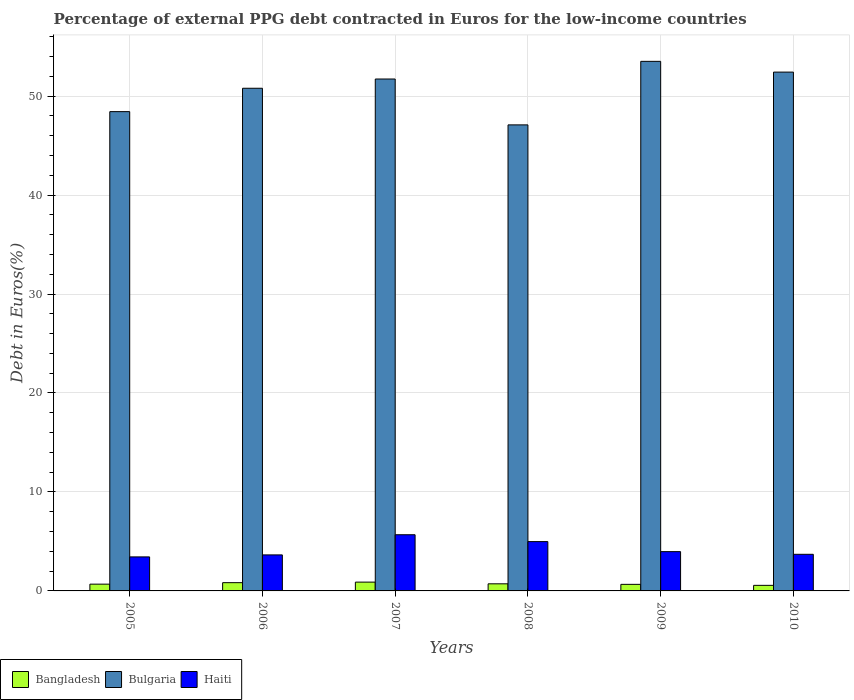How many different coloured bars are there?
Offer a terse response. 3. How many groups of bars are there?
Your answer should be very brief. 6. Are the number of bars on each tick of the X-axis equal?
Make the answer very short. Yes. In how many cases, is the number of bars for a given year not equal to the number of legend labels?
Offer a very short reply. 0. What is the percentage of external PPG debt contracted in Euros in Bangladesh in 2008?
Make the answer very short. 0.72. Across all years, what is the maximum percentage of external PPG debt contracted in Euros in Haiti?
Give a very brief answer. 5.68. Across all years, what is the minimum percentage of external PPG debt contracted in Euros in Bangladesh?
Provide a short and direct response. 0.56. In which year was the percentage of external PPG debt contracted in Euros in Bangladesh maximum?
Your answer should be very brief. 2007. What is the total percentage of external PPG debt contracted in Euros in Bangladesh in the graph?
Give a very brief answer. 4.35. What is the difference between the percentage of external PPG debt contracted in Euros in Bangladesh in 2008 and that in 2010?
Provide a short and direct response. 0.15. What is the difference between the percentage of external PPG debt contracted in Euros in Bulgaria in 2005 and the percentage of external PPG debt contracted in Euros in Haiti in 2006?
Your response must be concise. 44.79. What is the average percentage of external PPG debt contracted in Euros in Bangladesh per year?
Provide a succinct answer. 0.73. In the year 2005, what is the difference between the percentage of external PPG debt contracted in Euros in Haiti and percentage of external PPG debt contracted in Euros in Bulgaria?
Ensure brevity in your answer.  -44.99. What is the ratio of the percentage of external PPG debt contracted in Euros in Bulgaria in 2006 to that in 2010?
Your answer should be compact. 0.97. What is the difference between the highest and the second highest percentage of external PPG debt contracted in Euros in Bulgaria?
Your answer should be compact. 1.09. What is the difference between the highest and the lowest percentage of external PPG debt contracted in Euros in Bulgaria?
Ensure brevity in your answer.  6.42. What does the 1st bar from the right in 2008 represents?
Offer a terse response. Haiti. Is it the case that in every year, the sum of the percentage of external PPG debt contracted in Euros in Bulgaria and percentage of external PPG debt contracted in Euros in Haiti is greater than the percentage of external PPG debt contracted in Euros in Bangladesh?
Make the answer very short. Yes. How many bars are there?
Your answer should be compact. 18. Are all the bars in the graph horizontal?
Your response must be concise. No. How are the legend labels stacked?
Offer a very short reply. Horizontal. What is the title of the graph?
Provide a short and direct response. Percentage of external PPG debt contracted in Euros for the low-income countries. Does "Russian Federation" appear as one of the legend labels in the graph?
Offer a terse response. No. What is the label or title of the X-axis?
Offer a terse response. Years. What is the label or title of the Y-axis?
Make the answer very short. Debt in Euros(%). What is the Debt in Euros(%) in Bangladesh in 2005?
Give a very brief answer. 0.68. What is the Debt in Euros(%) of Bulgaria in 2005?
Your answer should be compact. 48.43. What is the Debt in Euros(%) of Haiti in 2005?
Provide a short and direct response. 3.44. What is the Debt in Euros(%) of Bangladesh in 2006?
Offer a terse response. 0.83. What is the Debt in Euros(%) of Bulgaria in 2006?
Keep it short and to the point. 50.79. What is the Debt in Euros(%) in Haiti in 2006?
Make the answer very short. 3.64. What is the Debt in Euros(%) in Bangladesh in 2007?
Your response must be concise. 0.89. What is the Debt in Euros(%) of Bulgaria in 2007?
Ensure brevity in your answer.  51.72. What is the Debt in Euros(%) of Haiti in 2007?
Offer a terse response. 5.68. What is the Debt in Euros(%) of Bangladesh in 2008?
Make the answer very short. 0.72. What is the Debt in Euros(%) in Bulgaria in 2008?
Give a very brief answer. 47.09. What is the Debt in Euros(%) in Haiti in 2008?
Give a very brief answer. 4.98. What is the Debt in Euros(%) in Bangladesh in 2009?
Make the answer very short. 0.66. What is the Debt in Euros(%) in Bulgaria in 2009?
Your answer should be compact. 53.51. What is the Debt in Euros(%) of Haiti in 2009?
Offer a very short reply. 3.97. What is the Debt in Euros(%) in Bangladesh in 2010?
Provide a succinct answer. 0.56. What is the Debt in Euros(%) of Bulgaria in 2010?
Provide a short and direct response. 52.42. What is the Debt in Euros(%) in Haiti in 2010?
Offer a terse response. 3.7. Across all years, what is the maximum Debt in Euros(%) of Bangladesh?
Make the answer very short. 0.89. Across all years, what is the maximum Debt in Euros(%) in Bulgaria?
Provide a succinct answer. 53.51. Across all years, what is the maximum Debt in Euros(%) in Haiti?
Keep it short and to the point. 5.68. Across all years, what is the minimum Debt in Euros(%) of Bangladesh?
Provide a succinct answer. 0.56. Across all years, what is the minimum Debt in Euros(%) in Bulgaria?
Give a very brief answer. 47.09. Across all years, what is the minimum Debt in Euros(%) in Haiti?
Keep it short and to the point. 3.44. What is the total Debt in Euros(%) of Bangladesh in the graph?
Give a very brief answer. 4.35. What is the total Debt in Euros(%) in Bulgaria in the graph?
Your answer should be compact. 303.97. What is the total Debt in Euros(%) in Haiti in the graph?
Your response must be concise. 25.41. What is the difference between the Debt in Euros(%) in Bangladesh in 2005 and that in 2006?
Make the answer very short. -0.15. What is the difference between the Debt in Euros(%) in Bulgaria in 2005 and that in 2006?
Offer a very short reply. -2.36. What is the difference between the Debt in Euros(%) of Haiti in 2005 and that in 2006?
Keep it short and to the point. -0.2. What is the difference between the Debt in Euros(%) of Bangladesh in 2005 and that in 2007?
Keep it short and to the point. -0.21. What is the difference between the Debt in Euros(%) of Bulgaria in 2005 and that in 2007?
Provide a succinct answer. -3.3. What is the difference between the Debt in Euros(%) of Haiti in 2005 and that in 2007?
Offer a very short reply. -2.24. What is the difference between the Debt in Euros(%) of Bangladesh in 2005 and that in 2008?
Ensure brevity in your answer.  -0.03. What is the difference between the Debt in Euros(%) of Bulgaria in 2005 and that in 2008?
Your response must be concise. 1.34. What is the difference between the Debt in Euros(%) of Haiti in 2005 and that in 2008?
Ensure brevity in your answer.  -1.54. What is the difference between the Debt in Euros(%) of Bangladesh in 2005 and that in 2009?
Your answer should be very brief. 0.02. What is the difference between the Debt in Euros(%) in Bulgaria in 2005 and that in 2009?
Your answer should be compact. -5.08. What is the difference between the Debt in Euros(%) of Haiti in 2005 and that in 2009?
Provide a short and direct response. -0.53. What is the difference between the Debt in Euros(%) of Bangladesh in 2005 and that in 2010?
Offer a terse response. 0.12. What is the difference between the Debt in Euros(%) in Bulgaria in 2005 and that in 2010?
Your answer should be very brief. -3.99. What is the difference between the Debt in Euros(%) of Haiti in 2005 and that in 2010?
Your response must be concise. -0.26. What is the difference between the Debt in Euros(%) of Bangladesh in 2006 and that in 2007?
Provide a succinct answer. -0.06. What is the difference between the Debt in Euros(%) of Bulgaria in 2006 and that in 2007?
Your answer should be compact. -0.93. What is the difference between the Debt in Euros(%) in Haiti in 2006 and that in 2007?
Give a very brief answer. -2.04. What is the difference between the Debt in Euros(%) in Bangladesh in 2006 and that in 2008?
Give a very brief answer. 0.12. What is the difference between the Debt in Euros(%) of Bulgaria in 2006 and that in 2008?
Give a very brief answer. 3.7. What is the difference between the Debt in Euros(%) in Haiti in 2006 and that in 2008?
Offer a terse response. -1.34. What is the difference between the Debt in Euros(%) in Bangladesh in 2006 and that in 2009?
Provide a succinct answer. 0.17. What is the difference between the Debt in Euros(%) of Bulgaria in 2006 and that in 2009?
Make the answer very short. -2.72. What is the difference between the Debt in Euros(%) of Haiti in 2006 and that in 2009?
Keep it short and to the point. -0.33. What is the difference between the Debt in Euros(%) of Bangladesh in 2006 and that in 2010?
Your answer should be very brief. 0.27. What is the difference between the Debt in Euros(%) of Bulgaria in 2006 and that in 2010?
Give a very brief answer. -1.63. What is the difference between the Debt in Euros(%) in Haiti in 2006 and that in 2010?
Your answer should be very brief. -0.06. What is the difference between the Debt in Euros(%) in Bangladesh in 2007 and that in 2008?
Your answer should be very brief. 0.17. What is the difference between the Debt in Euros(%) in Bulgaria in 2007 and that in 2008?
Give a very brief answer. 4.63. What is the difference between the Debt in Euros(%) in Haiti in 2007 and that in 2008?
Offer a terse response. 0.69. What is the difference between the Debt in Euros(%) in Bangladesh in 2007 and that in 2009?
Keep it short and to the point. 0.23. What is the difference between the Debt in Euros(%) in Bulgaria in 2007 and that in 2009?
Offer a very short reply. -1.78. What is the difference between the Debt in Euros(%) of Haiti in 2007 and that in 2009?
Provide a succinct answer. 1.71. What is the difference between the Debt in Euros(%) of Bangladesh in 2007 and that in 2010?
Your response must be concise. 0.33. What is the difference between the Debt in Euros(%) of Bulgaria in 2007 and that in 2010?
Your response must be concise. -0.7. What is the difference between the Debt in Euros(%) in Haiti in 2007 and that in 2010?
Give a very brief answer. 1.98. What is the difference between the Debt in Euros(%) in Bangladesh in 2008 and that in 2009?
Provide a succinct answer. 0.05. What is the difference between the Debt in Euros(%) of Bulgaria in 2008 and that in 2009?
Provide a short and direct response. -6.42. What is the difference between the Debt in Euros(%) in Haiti in 2008 and that in 2009?
Keep it short and to the point. 1.01. What is the difference between the Debt in Euros(%) in Bangladesh in 2008 and that in 2010?
Keep it short and to the point. 0.15. What is the difference between the Debt in Euros(%) in Bulgaria in 2008 and that in 2010?
Keep it short and to the point. -5.33. What is the difference between the Debt in Euros(%) in Haiti in 2008 and that in 2010?
Ensure brevity in your answer.  1.28. What is the difference between the Debt in Euros(%) of Bangladesh in 2009 and that in 2010?
Offer a very short reply. 0.1. What is the difference between the Debt in Euros(%) of Bulgaria in 2009 and that in 2010?
Offer a very short reply. 1.09. What is the difference between the Debt in Euros(%) in Haiti in 2009 and that in 2010?
Your answer should be compact. 0.27. What is the difference between the Debt in Euros(%) of Bangladesh in 2005 and the Debt in Euros(%) of Bulgaria in 2006?
Ensure brevity in your answer.  -50.11. What is the difference between the Debt in Euros(%) in Bangladesh in 2005 and the Debt in Euros(%) in Haiti in 2006?
Give a very brief answer. -2.96. What is the difference between the Debt in Euros(%) in Bulgaria in 2005 and the Debt in Euros(%) in Haiti in 2006?
Offer a terse response. 44.79. What is the difference between the Debt in Euros(%) of Bangladesh in 2005 and the Debt in Euros(%) of Bulgaria in 2007?
Make the answer very short. -51.04. What is the difference between the Debt in Euros(%) of Bangladesh in 2005 and the Debt in Euros(%) of Haiti in 2007?
Provide a succinct answer. -4.99. What is the difference between the Debt in Euros(%) of Bulgaria in 2005 and the Debt in Euros(%) of Haiti in 2007?
Your answer should be very brief. 42.75. What is the difference between the Debt in Euros(%) in Bangladesh in 2005 and the Debt in Euros(%) in Bulgaria in 2008?
Offer a very short reply. -46.41. What is the difference between the Debt in Euros(%) in Bangladesh in 2005 and the Debt in Euros(%) in Haiti in 2008?
Your answer should be compact. -4.3. What is the difference between the Debt in Euros(%) of Bulgaria in 2005 and the Debt in Euros(%) of Haiti in 2008?
Your response must be concise. 43.45. What is the difference between the Debt in Euros(%) of Bangladesh in 2005 and the Debt in Euros(%) of Bulgaria in 2009?
Give a very brief answer. -52.82. What is the difference between the Debt in Euros(%) of Bangladesh in 2005 and the Debt in Euros(%) of Haiti in 2009?
Make the answer very short. -3.29. What is the difference between the Debt in Euros(%) of Bulgaria in 2005 and the Debt in Euros(%) of Haiti in 2009?
Make the answer very short. 44.46. What is the difference between the Debt in Euros(%) of Bangladesh in 2005 and the Debt in Euros(%) of Bulgaria in 2010?
Keep it short and to the point. -51.74. What is the difference between the Debt in Euros(%) in Bangladesh in 2005 and the Debt in Euros(%) in Haiti in 2010?
Give a very brief answer. -3.02. What is the difference between the Debt in Euros(%) in Bulgaria in 2005 and the Debt in Euros(%) in Haiti in 2010?
Your answer should be compact. 44.73. What is the difference between the Debt in Euros(%) in Bangladesh in 2006 and the Debt in Euros(%) in Bulgaria in 2007?
Your response must be concise. -50.89. What is the difference between the Debt in Euros(%) in Bangladesh in 2006 and the Debt in Euros(%) in Haiti in 2007?
Keep it short and to the point. -4.84. What is the difference between the Debt in Euros(%) of Bulgaria in 2006 and the Debt in Euros(%) of Haiti in 2007?
Offer a very short reply. 45.11. What is the difference between the Debt in Euros(%) in Bangladesh in 2006 and the Debt in Euros(%) in Bulgaria in 2008?
Offer a very short reply. -46.26. What is the difference between the Debt in Euros(%) in Bangladesh in 2006 and the Debt in Euros(%) in Haiti in 2008?
Your answer should be compact. -4.15. What is the difference between the Debt in Euros(%) in Bulgaria in 2006 and the Debt in Euros(%) in Haiti in 2008?
Provide a succinct answer. 45.81. What is the difference between the Debt in Euros(%) in Bangladesh in 2006 and the Debt in Euros(%) in Bulgaria in 2009?
Your answer should be very brief. -52.67. What is the difference between the Debt in Euros(%) in Bangladesh in 2006 and the Debt in Euros(%) in Haiti in 2009?
Your response must be concise. -3.13. What is the difference between the Debt in Euros(%) in Bulgaria in 2006 and the Debt in Euros(%) in Haiti in 2009?
Ensure brevity in your answer.  46.82. What is the difference between the Debt in Euros(%) of Bangladesh in 2006 and the Debt in Euros(%) of Bulgaria in 2010?
Keep it short and to the point. -51.59. What is the difference between the Debt in Euros(%) of Bangladesh in 2006 and the Debt in Euros(%) of Haiti in 2010?
Keep it short and to the point. -2.87. What is the difference between the Debt in Euros(%) of Bulgaria in 2006 and the Debt in Euros(%) of Haiti in 2010?
Your answer should be very brief. 47.09. What is the difference between the Debt in Euros(%) of Bangladesh in 2007 and the Debt in Euros(%) of Bulgaria in 2008?
Ensure brevity in your answer.  -46.2. What is the difference between the Debt in Euros(%) of Bangladesh in 2007 and the Debt in Euros(%) of Haiti in 2008?
Provide a succinct answer. -4.09. What is the difference between the Debt in Euros(%) of Bulgaria in 2007 and the Debt in Euros(%) of Haiti in 2008?
Your answer should be very brief. 46.74. What is the difference between the Debt in Euros(%) of Bangladesh in 2007 and the Debt in Euros(%) of Bulgaria in 2009?
Give a very brief answer. -52.62. What is the difference between the Debt in Euros(%) in Bangladesh in 2007 and the Debt in Euros(%) in Haiti in 2009?
Provide a short and direct response. -3.08. What is the difference between the Debt in Euros(%) of Bulgaria in 2007 and the Debt in Euros(%) of Haiti in 2009?
Offer a terse response. 47.76. What is the difference between the Debt in Euros(%) in Bangladesh in 2007 and the Debt in Euros(%) in Bulgaria in 2010?
Keep it short and to the point. -51.53. What is the difference between the Debt in Euros(%) in Bangladesh in 2007 and the Debt in Euros(%) in Haiti in 2010?
Make the answer very short. -2.81. What is the difference between the Debt in Euros(%) in Bulgaria in 2007 and the Debt in Euros(%) in Haiti in 2010?
Make the answer very short. 48.03. What is the difference between the Debt in Euros(%) in Bangladesh in 2008 and the Debt in Euros(%) in Bulgaria in 2009?
Your answer should be very brief. -52.79. What is the difference between the Debt in Euros(%) in Bangladesh in 2008 and the Debt in Euros(%) in Haiti in 2009?
Offer a terse response. -3.25. What is the difference between the Debt in Euros(%) of Bulgaria in 2008 and the Debt in Euros(%) of Haiti in 2009?
Offer a very short reply. 43.12. What is the difference between the Debt in Euros(%) of Bangladesh in 2008 and the Debt in Euros(%) of Bulgaria in 2010?
Offer a very short reply. -51.71. What is the difference between the Debt in Euros(%) of Bangladesh in 2008 and the Debt in Euros(%) of Haiti in 2010?
Offer a terse response. -2.98. What is the difference between the Debt in Euros(%) of Bulgaria in 2008 and the Debt in Euros(%) of Haiti in 2010?
Offer a very short reply. 43.39. What is the difference between the Debt in Euros(%) in Bangladesh in 2009 and the Debt in Euros(%) in Bulgaria in 2010?
Provide a succinct answer. -51.76. What is the difference between the Debt in Euros(%) of Bangladesh in 2009 and the Debt in Euros(%) of Haiti in 2010?
Give a very brief answer. -3.04. What is the difference between the Debt in Euros(%) in Bulgaria in 2009 and the Debt in Euros(%) in Haiti in 2010?
Keep it short and to the point. 49.81. What is the average Debt in Euros(%) in Bangladesh per year?
Offer a terse response. 0.73. What is the average Debt in Euros(%) of Bulgaria per year?
Provide a succinct answer. 50.66. What is the average Debt in Euros(%) of Haiti per year?
Keep it short and to the point. 4.23. In the year 2005, what is the difference between the Debt in Euros(%) in Bangladesh and Debt in Euros(%) in Bulgaria?
Offer a terse response. -47.74. In the year 2005, what is the difference between the Debt in Euros(%) of Bangladesh and Debt in Euros(%) of Haiti?
Make the answer very short. -2.75. In the year 2005, what is the difference between the Debt in Euros(%) in Bulgaria and Debt in Euros(%) in Haiti?
Your answer should be very brief. 44.99. In the year 2006, what is the difference between the Debt in Euros(%) of Bangladesh and Debt in Euros(%) of Bulgaria?
Provide a short and direct response. -49.96. In the year 2006, what is the difference between the Debt in Euros(%) of Bangladesh and Debt in Euros(%) of Haiti?
Give a very brief answer. -2.81. In the year 2006, what is the difference between the Debt in Euros(%) in Bulgaria and Debt in Euros(%) in Haiti?
Your response must be concise. 47.15. In the year 2007, what is the difference between the Debt in Euros(%) in Bangladesh and Debt in Euros(%) in Bulgaria?
Your answer should be very brief. -50.84. In the year 2007, what is the difference between the Debt in Euros(%) in Bangladesh and Debt in Euros(%) in Haiti?
Your response must be concise. -4.79. In the year 2007, what is the difference between the Debt in Euros(%) in Bulgaria and Debt in Euros(%) in Haiti?
Offer a very short reply. 46.05. In the year 2008, what is the difference between the Debt in Euros(%) in Bangladesh and Debt in Euros(%) in Bulgaria?
Ensure brevity in your answer.  -46.37. In the year 2008, what is the difference between the Debt in Euros(%) of Bangladesh and Debt in Euros(%) of Haiti?
Keep it short and to the point. -4.26. In the year 2008, what is the difference between the Debt in Euros(%) of Bulgaria and Debt in Euros(%) of Haiti?
Ensure brevity in your answer.  42.11. In the year 2009, what is the difference between the Debt in Euros(%) in Bangladesh and Debt in Euros(%) in Bulgaria?
Keep it short and to the point. -52.84. In the year 2009, what is the difference between the Debt in Euros(%) in Bangladesh and Debt in Euros(%) in Haiti?
Ensure brevity in your answer.  -3.31. In the year 2009, what is the difference between the Debt in Euros(%) of Bulgaria and Debt in Euros(%) of Haiti?
Provide a short and direct response. 49.54. In the year 2010, what is the difference between the Debt in Euros(%) of Bangladesh and Debt in Euros(%) of Bulgaria?
Make the answer very short. -51.86. In the year 2010, what is the difference between the Debt in Euros(%) in Bangladesh and Debt in Euros(%) in Haiti?
Give a very brief answer. -3.14. In the year 2010, what is the difference between the Debt in Euros(%) in Bulgaria and Debt in Euros(%) in Haiti?
Provide a succinct answer. 48.72. What is the ratio of the Debt in Euros(%) of Bangladesh in 2005 to that in 2006?
Ensure brevity in your answer.  0.82. What is the ratio of the Debt in Euros(%) of Bulgaria in 2005 to that in 2006?
Your response must be concise. 0.95. What is the ratio of the Debt in Euros(%) of Haiti in 2005 to that in 2006?
Your response must be concise. 0.94. What is the ratio of the Debt in Euros(%) in Bangladesh in 2005 to that in 2007?
Your answer should be compact. 0.77. What is the ratio of the Debt in Euros(%) of Bulgaria in 2005 to that in 2007?
Provide a short and direct response. 0.94. What is the ratio of the Debt in Euros(%) of Haiti in 2005 to that in 2007?
Keep it short and to the point. 0.61. What is the ratio of the Debt in Euros(%) of Bangladesh in 2005 to that in 2008?
Your answer should be compact. 0.95. What is the ratio of the Debt in Euros(%) of Bulgaria in 2005 to that in 2008?
Offer a terse response. 1.03. What is the ratio of the Debt in Euros(%) of Haiti in 2005 to that in 2008?
Offer a terse response. 0.69. What is the ratio of the Debt in Euros(%) of Bangladesh in 2005 to that in 2009?
Give a very brief answer. 1.03. What is the ratio of the Debt in Euros(%) in Bulgaria in 2005 to that in 2009?
Make the answer very short. 0.91. What is the ratio of the Debt in Euros(%) in Haiti in 2005 to that in 2009?
Offer a very short reply. 0.87. What is the ratio of the Debt in Euros(%) of Bangladesh in 2005 to that in 2010?
Make the answer very short. 1.22. What is the ratio of the Debt in Euros(%) of Bulgaria in 2005 to that in 2010?
Provide a short and direct response. 0.92. What is the ratio of the Debt in Euros(%) in Haiti in 2005 to that in 2010?
Offer a very short reply. 0.93. What is the ratio of the Debt in Euros(%) in Bangladesh in 2006 to that in 2007?
Give a very brief answer. 0.94. What is the ratio of the Debt in Euros(%) of Bulgaria in 2006 to that in 2007?
Your answer should be compact. 0.98. What is the ratio of the Debt in Euros(%) in Haiti in 2006 to that in 2007?
Offer a terse response. 0.64. What is the ratio of the Debt in Euros(%) in Bangladesh in 2006 to that in 2008?
Your answer should be very brief. 1.16. What is the ratio of the Debt in Euros(%) in Bulgaria in 2006 to that in 2008?
Provide a short and direct response. 1.08. What is the ratio of the Debt in Euros(%) of Haiti in 2006 to that in 2008?
Your answer should be very brief. 0.73. What is the ratio of the Debt in Euros(%) of Bangladesh in 2006 to that in 2009?
Ensure brevity in your answer.  1.26. What is the ratio of the Debt in Euros(%) of Bulgaria in 2006 to that in 2009?
Give a very brief answer. 0.95. What is the ratio of the Debt in Euros(%) in Haiti in 2006 to that in 2009?
Provide a succinct answer. 0.92. What is the ratio of the Debt in Euros(%) in Bangladesh in 2006 to that in 2010?
Offer a terse response. 1.48. What is the ratio of the Debt in Euros(%) in Bulgaria in 2006 to that in 2010?
Give a very brief answer. 0.97. What is the ratio of the Debt in Euros(%) of Haiti in 2006 to that in 2010?
Provide a short and direct response. 0.98. What is the ratio of the Debt in Euros(%) of Bangladesh in 2007 to that in 2008?
Make the answer very short. 1.24. What is the ratio of the Debt in Euros(%) in Bulgaria in 2007 to that in 2008?
Give a very brief answer. 1.1. What is the ratio of the Debt in Euros(%) in Haiti in 2007 to that in 2008?
Offer a very short reply. 1.14. What is the ratio of the Debt in Euros(%) in Bangladesh in 2007 to that in 2009?
Give a very brief answer. 1.34. What is the ratio of the Debt in Euros(%) of Bulgaria in 2007 to that in 2009?
Keep it short and to the point. 0.97. What is the ratio of the Debt in Euros(%) of Haiti in 2007 to that in 2009?
Your response must be concise. 1.43. What is the ratio of the Debt in Euros(%) of Bangladesh in 2007 to that in 2010?
Make the answer very short. 1.58. What is the ratio of the Debt in Euros(%) of Bulgaria in 2007 to that in 2010?
Your answer should be very brief. 0.99. What is the ratio of the Debt in Euros(%) in Haiti in 2007 to that in 2010?
Your answer should be very brief. 1.53. What is the ratio of the Debt in Euros(%) of Bangladesh in 2008 to that in 2009?
Make the answer very short. 1.08. What is the ratio of the Debt in Euros(%) of Bulgaria in 2008 to that in 2009?
Your answer should be compact. 0.88. What is the ratio of the Debt in Euros(%) of Haiti in 2008 to that in 2009?
Your answer should be compact. 1.26. What is the ratio of the Debt in Euros(%) in Bangladesh in 2008 to that in 2010?
Offer a terse response. 1.27. What is the ratio of the Debt in Euros(%) of Bulgaria in 2008 to that in 2010?
Provide a succinct answer. 0.9. What is the ratio of the Debt in Euros(%) of Haiti in 2008 to that in 2010?
Offer a very short reply. 1.35. What is the ratio of the Debt in Euros(%) in Bangladesh in 2009 to that in 2010?
Your answer should be compact. 1.18. What is the ratio of the Debt in Euros(%) of Bulgaria in 2009 to that in 2010?
Your answer should be compact. 1.02. What is the ratio of the Debt in Euros(%) of Haiti in 2009 to that in 2010?
Offer a terse response. 1.07. What is the difference between the highest and the second highest Debt in Euros(%) of Bangladesh?
Make the answer very short. 0.06. What is the difference between the highest and the second highest Debt in Euros(%) in Bulgaria?
Offer a very short reply. 1.09. What is the difference between the highest and the second highest Debt in Euros(%) in Haiti?
Provide a short and direct response. 0.69. What is the difference between the highest and the lowest Debt in Euros(%) of Bangladesh?
Your answer should be compact. 0.33. What is the difference between the highest and the lowest Debt in Euros(%) in Bulgaria?
Keep it short and to the point. 6.42. What is the difference between the highest and the lowest Debt in Euros(%) of Haiti?
Your answer should be very brief. 2.24. 